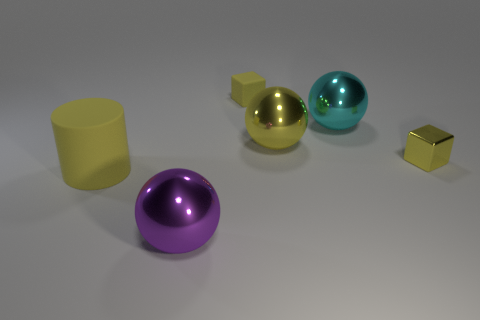Add 2 big rubber cylinders. How many objects exist? 8 Subtract all cylinders. How many objects are left? 5 Add 4 large things. How many large things are left? 8 Add 2 small metal cubes. How many small metal cubes exist? 3 Subtract 0 gray cubes. How many objects are left? 6 Subtract all brown metal blocks. Subtract all small matte cubes. How many objects are left? 5 